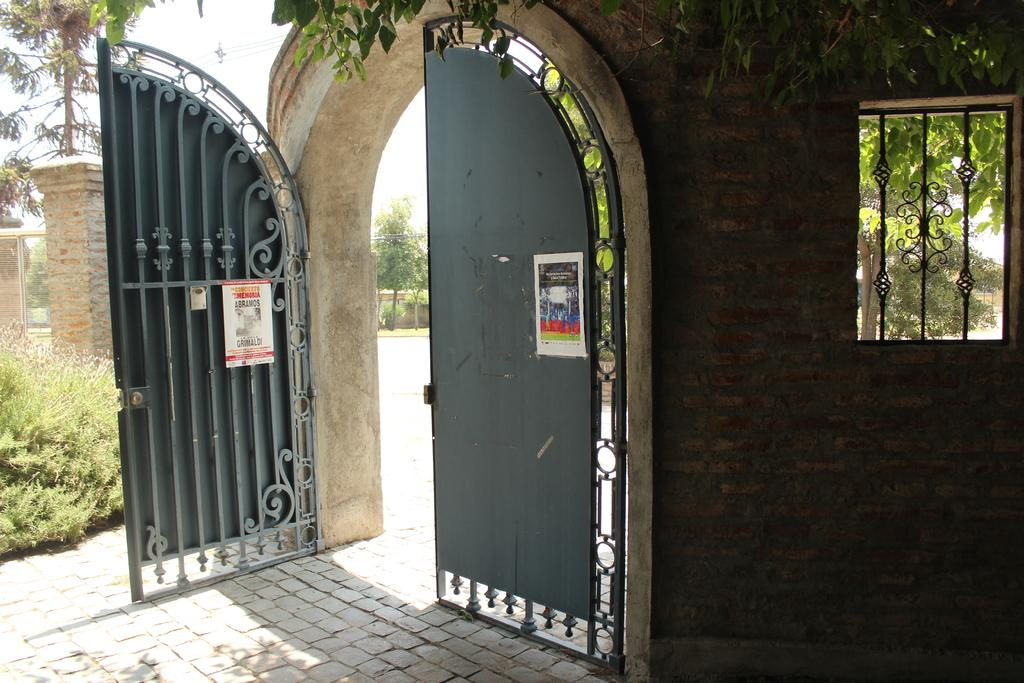What type of vegetation can be seen in the image? There are trees in the image. What is the metal gate attached to? The metal gate is attached to a wall. What can be found on the metal gate? There are posters on the gate. Where is the window located in the image? The window is on the right side of the image. What is the condition of the sky in the image? The sky is cloudy in the image. What type of trouble is the father experiencing in the image? There is no father or any indication of trouble present in the image. Is there a balloon visible in the image? No, there is no balloon present in the image. 